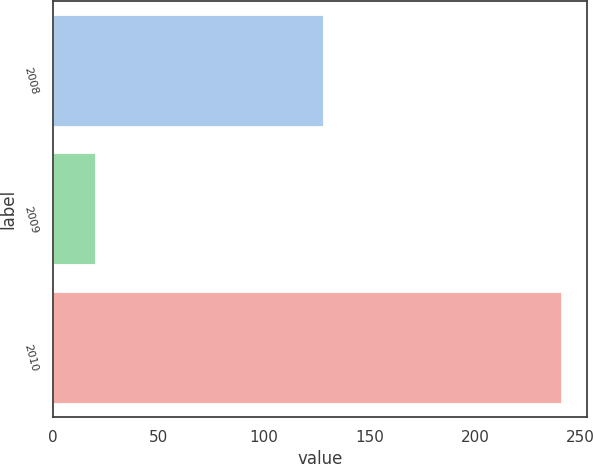Convert chart to OTSL. <chart><loc_0><loc_0><loc_500><loc_500><bar_chart><fcel>2008<fcel>2009<fcel>2010<nl><fcel>128<fcel>20<fcel>241<nl></chart> 